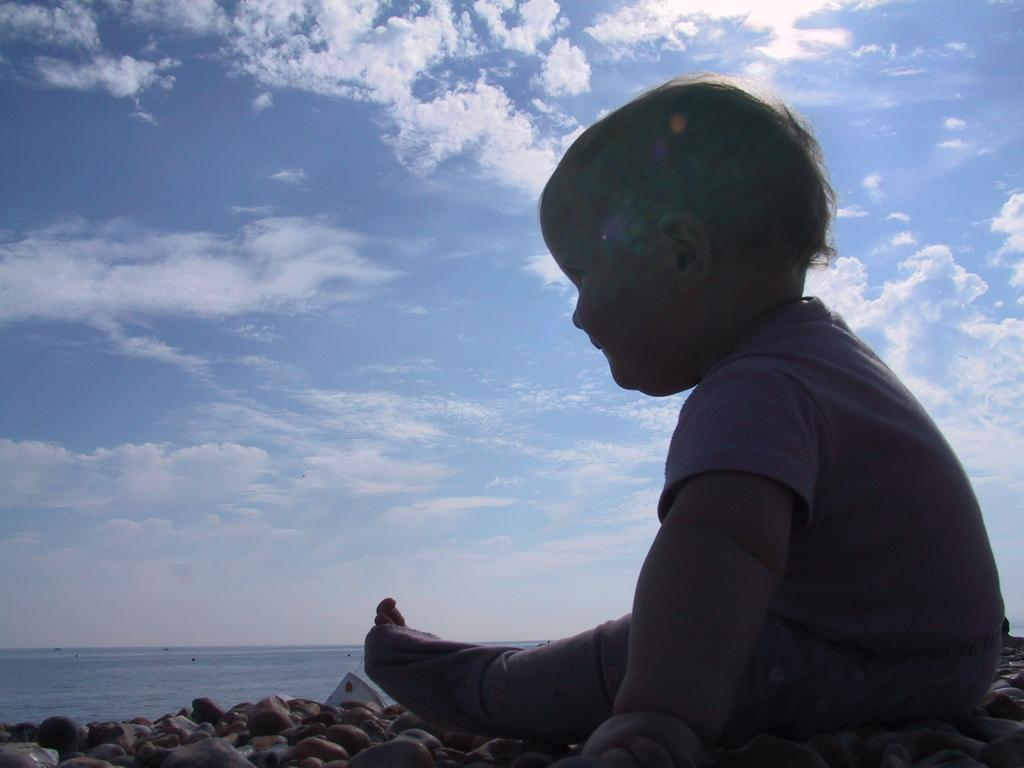What is the main subject on the left side of the image? There is a baby sitting on the left side of the image. What can be seen in the background of the image? The sky, clouds, water, a tent, stones, and a few other objects are present in the background of the image. Can you describe the sky in the background? The sky is visible in the background of the image. What type of natural feature is visible in the background? Water is visible in the background of the image. What type of shelter is present in the background? There is a tent in the background of the image. What statement does the baby make in the image? The image does not depict the baby making any statements, as it is a still image and not a video or audio recording. Can you see a squirrel in the image? There is no squirrel present in the image. 